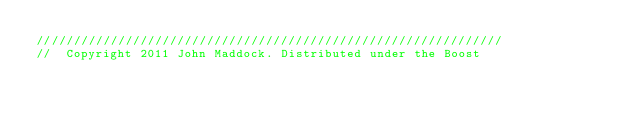<code> <loc_0><loc_0><loc_500><loc_500><_C++_>///////////////////////////////////////////////////////////////
//  Copyright 2011 John Maddock. Distributed under the Boost</code> 